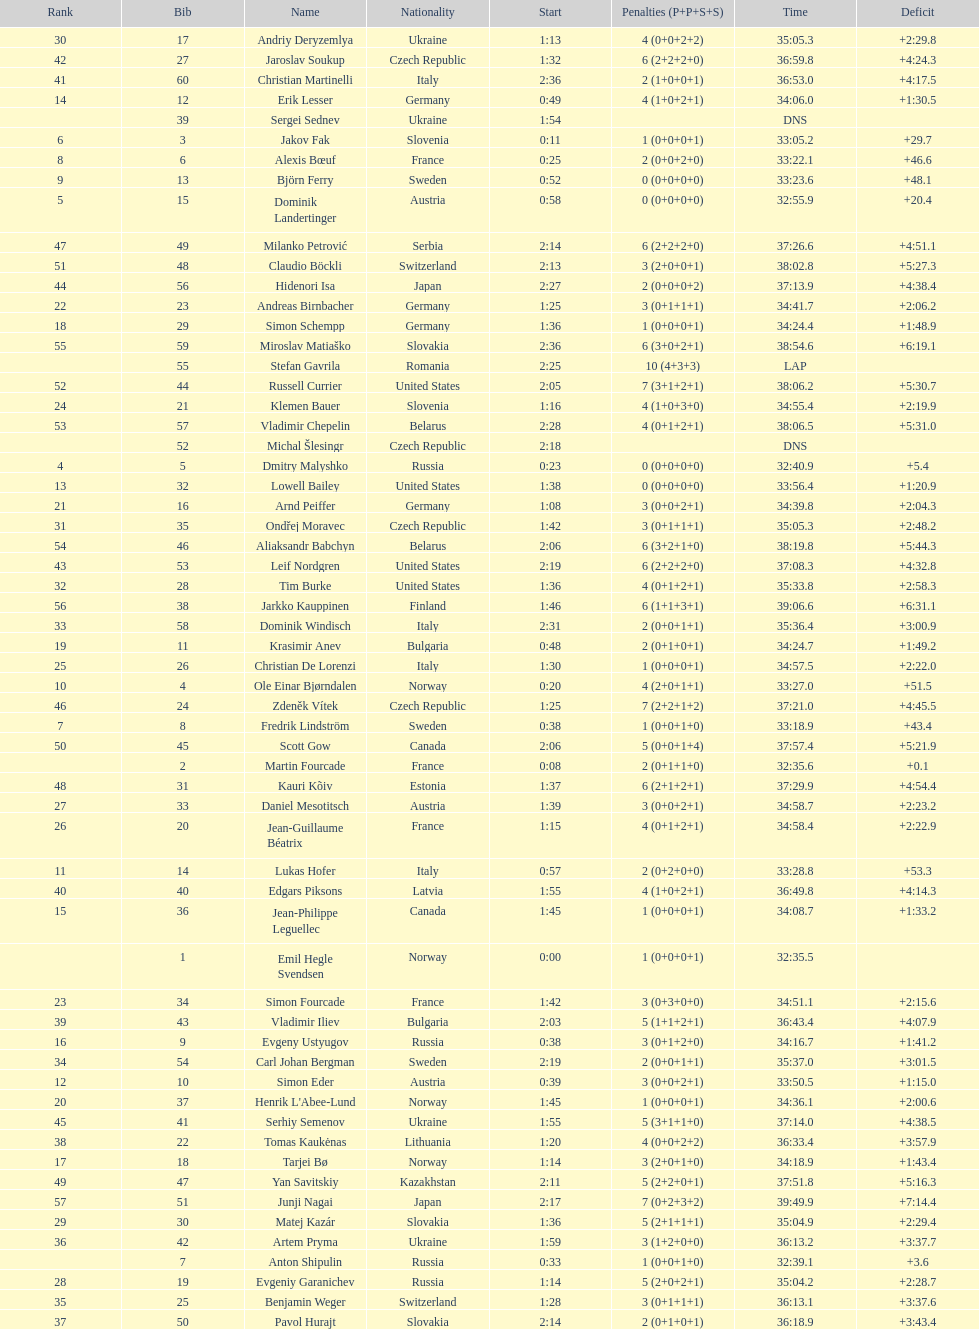What is the total number of participants between norway and france? 7. 